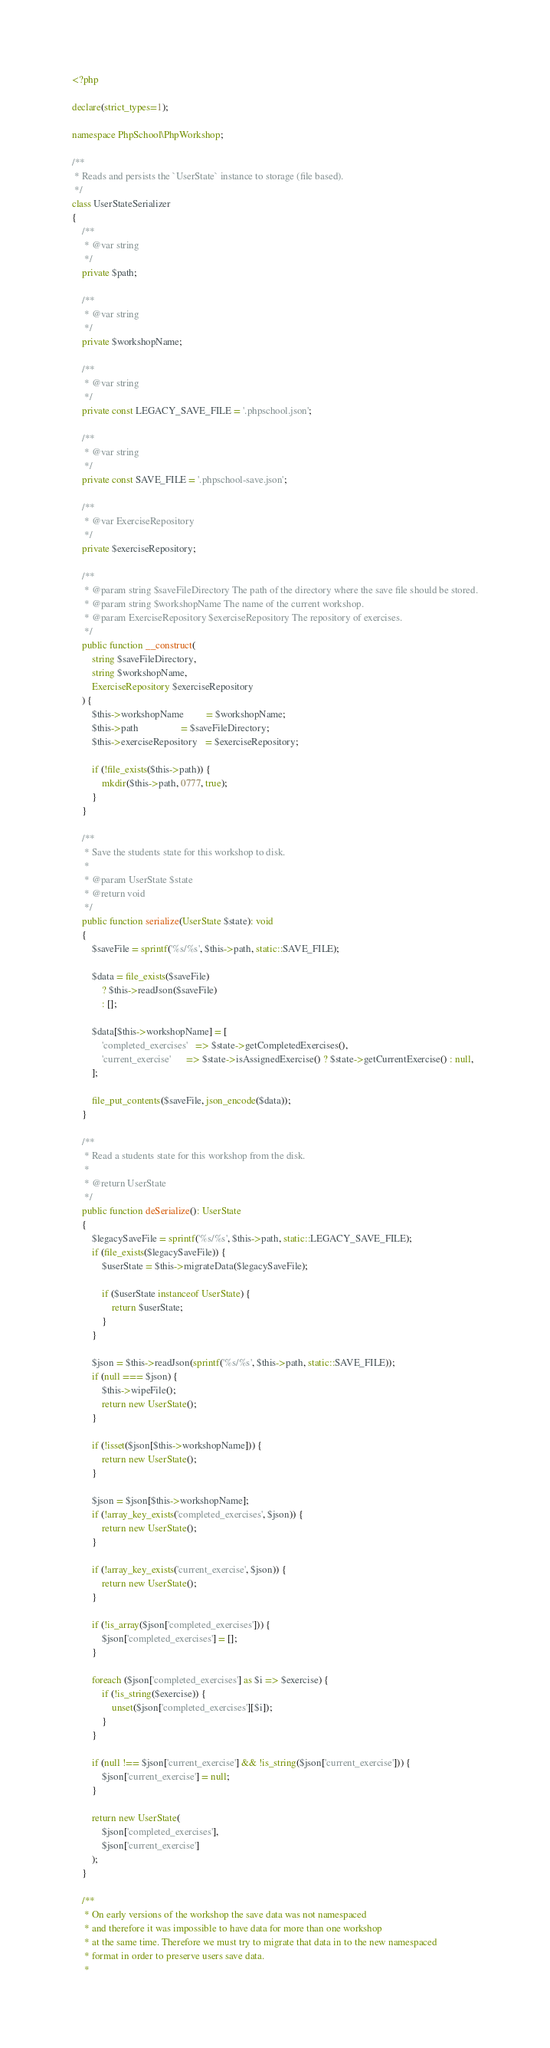<code> <loc_0><loc_0><loc_500><loc_500><_PHP_><?php

declare(strict_types=1);

namespace PhpSchool\PhpWorkshop;

/**
 * Reads and persists the `UserState` instance to storage (file based).
 */
class UserStateSerializer
{
    /**
     * @var string
     */
    private $path;

    /**
     * @var string
     */
    private $workshopName;

    /**
     * @var string
     */
    private const LEGACY_SAVE_FILE = '.phpschool.json';

    /**
     * @var string
     */
    private const SAVE_FILE = '.phpschool-save.json';

    /**
     * @var ExerciseRepository
     */
    private $exerciseRepository;

    /**
     * @param string $saveFileDirectory The path of the directory where the save file should be stored.
     * @param string $workshopName The name of the current workshop.
     * @param ExerciseRepository $exerciseRepository The repository of exercises.
     */
    public function __construct(
        string $saveFileDirectory,
        string $workshopName,
        ExerciseRepository $exerciseRepository
    ) {
        $this->workshopName         = $workshopName;
        $this->path                 = $saveFileDirectory;
        $this->exerciseRepository   = $exerciseRepository;

        if (!file_exists($this->path)) {
            mkdir($this->path, 0777, true);
        }
    }

    /**
     * Save the students state for this workshop to disk.
     *
     * @param UserState $state
     * @return void
     */
    public function serialize(UserState $state): void
    {
        $saveFile = sprintf('%s/%s', $this->path, static::SAVE_FILE);

        $data = file_exists($saveFile)
            ? $this->readJson($saveFile)
            : [];

        $data[$this->workshopName] = [
            'completed_exercises'   => $state->getCompletedExercises(),
            'current_exercise'      => $state->isAssignedExercise() ? $state->getCurrentExercise() : null,
        ];

        file_put_contents($saveFile, json_encode($data));
    }

    /**
     * Read a students state for this workshop from the disk.
     *
     * @return UserState
     */
    public function deSerialize(): UserState
    {
        $legacySaveFile = sprintf('%s/%s', $this->path, static::LEGACY_SAVE_FILE);
        if (file_exists($legacySaveFile)) {
            $userState = $this->migrateData($legacySaveFile);

            if ($userState instanceof UserState) {
                return $userState;
            }
        }

        $json = $this->readJson(sprintf('%s/%s', $this->path, static::SAVE_FILE));
        if (null === $json) {
            $this->wipeFile();
            return new UserState();
        }

        if (!isset($json[$this->workshopName])) {
            return new UserState();
        }

        $json = $json[$this->workshopName];
        if (!array_key_exists('completed_exercises', $json)) {
            return new UserState();
        }

        if (!array_key_exists('current_exercise', $json)) {
            return new UserState();
        }

        if (!is_array($json['completed_exercises'])) {
            $json['completed_exercises'] = [];
        }

        foreach ($json['completed_exercises'] as $i => $exercise) {
            if (!is_string($exercise)) {
                unset($json['completed_exercises'][$i]);
            }
        }

        if (null !== $json['current_exercise'] && !is_string($json['current_exercise'])) {
            $json['current_exercise'] = null;
        }

        return new UserState(
            $json['completed_exercises'],
            $json['current_exercise']
        );
    }

    /**
     * On early versions of the workshop the save data was not namespaced
     * and therefore it was impossible to have data for more than one workshop
     * at the same time. Therefore we must try to migrate that data in to the new namespaced
     * format in order to preserve users save data.
     *</code> 